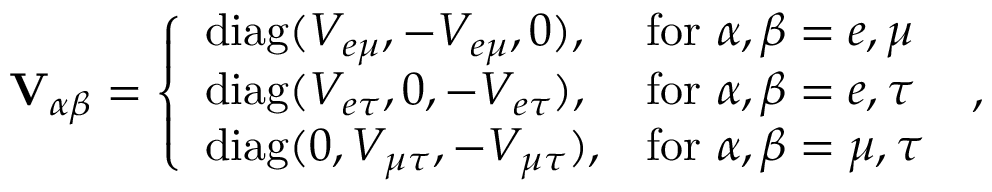Convert formula to latex. <formula><loc_0><loc_0><loc_500><loc_500>V _ { \alpha \beta } = \left \{ \begin{array} { l l } { d i a g ( V _ { e \mu } , - V _ { e \mu } , 0 ) , } & { f o r \alpha , \beta = e , \mu } \\ { d i a g ( V _ { e \tau } , 0 , - V _ { e \tau } ) , } & { f o r \alpha , \beta = e , \tau } \\ { d i a g ( 0 , V _ { \mu \tau } , - V _ { \mu \tau } ) , } & { f o r \alpha , \beta = \mu , \tau } \end{array} \, ,</formula> 